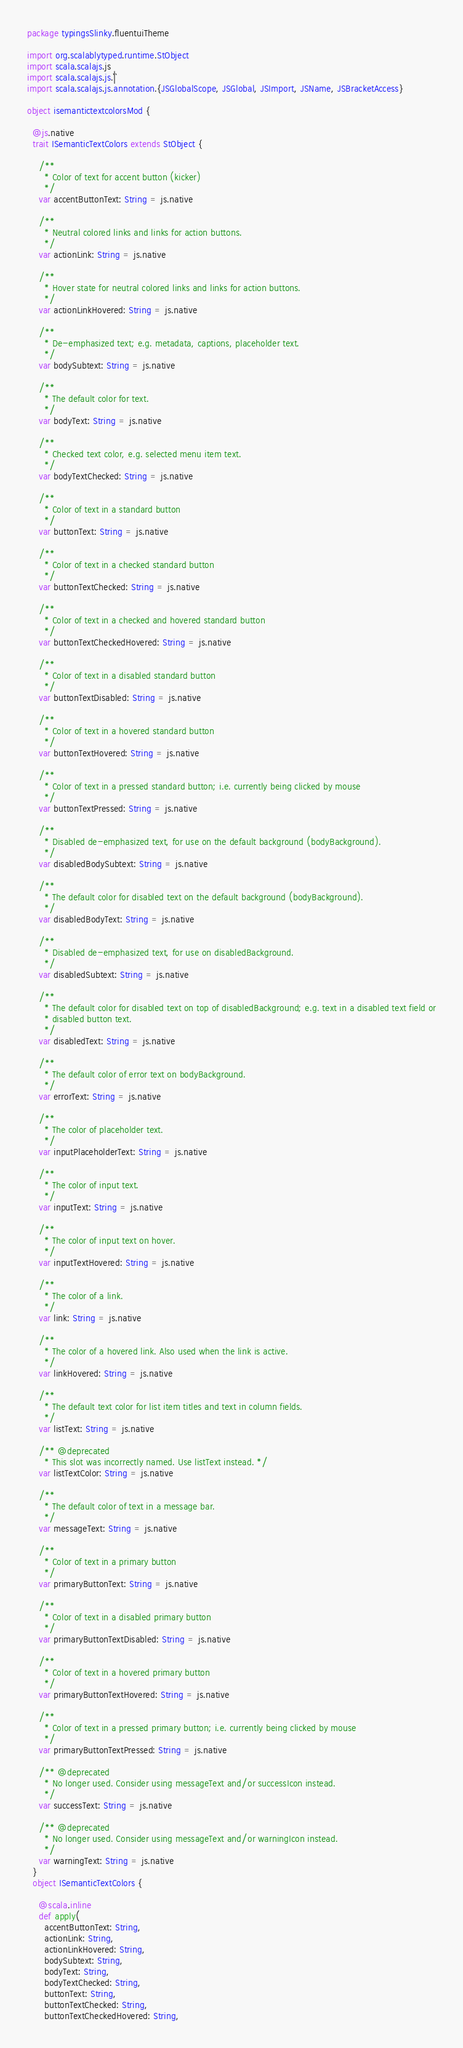Convert code to text. <code><loc_0><loc_0><loc_500><loc_500><_Scala_>package typingsSlinky.fluentuiTheme

import org.scalablytyped.runtime.StObject
import scala.scalajs.js
import scala.scalajs.js.`|`
import scala.scalajs.js.annotation.{JSGlobalScope, JSGlobal, JSImport, JSName, JSBracketAccess}

object isemantictextcolorsMod {
  
  @js.native
  trait ISemanticTextColors extends StObject {
    
    /**
      * Color of text for accent button (kicker)
      */
    var accentButtonText: String = js.native
    
    /**
      * Neutral colored links and links for action buttons.
      */
    var actionLink: String = js.native
    
    /**
      * Hover state for neutral colored links and links for action buttons.
      */
    var actionLinkHovered: String = js.native
    
    /**
      * De-emphasized text; e.g. metadata, captions, placeholder text.
      */
    var bodySubtext: String = js.native
    
    /**
      * The default color for text.
      */
    var bodyText: String = js.native
    
    /**
      * Checked text color, e.g. selected menu item text.
      */
    var bodyTextChecked: String = js.native
    
    /**
      * Color of text in a standard button
      */
    var buttonText: String = js.native
    
    /**
      * Color of text in a checked standard button
      */
    var buttonTextChecked: String = js.native
    
    /**
      * Color of text in a checked and hovered standard button
      */
    var buttonTextCheckedHovered: String = js.native
    
    /**
      * Color of text in a disabled standard button
      */
    var buttonTextDisabled: String = js.native
    
    /**
      * Color of text in a hovered standard button
      */
    var buttonTextHovered: String = js.native
    
    /**
      * Color of text in a pressed standard button; i.e. currently being clicked by mouse
      */
    var buttonTextPressed: String = js.native
    
    /**
      * Disabled de-emphasized text, for use on the default background (bodyBackground).
      */
    var disabledBodySubtext: String = js.native
    
    /**
      * The default color for disabled text on the default background (bodyBackground).
      */
    var disabledBodyText: String = js.native
    
    /**
      * Disabled de-emphasized text, for use on disabledBackground.
      */
    var disabledSubtext: String = js.native
    
    /**
      * The default color for disabled text on top of disabledBackground; e.g. text in a disabled text field or
      * disabled button text.
      */
    var disabledText: String = js.native
    
    /**
      * The default color of error text on bodyBackground.
      */
    var errorText: String = js.native
    
    /**
      * The color of placeholder text.
      */
    var inputPlaceholderText: String = js.native
    
    /**
      * The color of input text.
      */
    var inputText: String = js.native
    
    /**
      * The color of input text on hover.
      */
    var inputTextHovered: String = js.native
    
    /**
      * The color of a link.
      */
    var link: String = js.native
    
    /**
      * The color of a hovered link. Also used when the link is active.
      */
    var linkHovered: String = js.native
    
    /**
      * The default text color for list item titles and text in column fields.
      */
    var listText: String = js.native
    
    /** @deprecated
      * This slot was incorrectly named. Use listText instead. */
    var listTextColor: String = js.native
    
    /**
      * The default color of text in a message bar.
      */
    var messageText: String = js.native
    
    /**
      * Color of text in a primary button
      */
    var primaryButtonText: String = js.native
    
    /**
      * Color of text in a disabled primary button
      */
    var primaryButtonTextDisabled: String = js.native
    
    /**
      * Color of text in a hovered primary button
      */
    var primaryButtonTextHovered: String = js.native
    
    /**
      * Color of text in a pressed primary button; i.e. currently being clicked by mouse
      */
    var primaryButtonTextPressed: String = js.native
    
    /** @deprecated
      * No longer used. Consider using messageText and/or successIcon instead.
      */
    var successText: String = js.native
    
    /** @deprecated
      * No longer used. Consider using messageText and/or warningIcon instead.
      */
    var warningText: String = js.native
  }
  object ISemanticTextColors {
    
    @scala.inline
    def apply(
      accentButtonText: String,
      actionLink: String,
      actionLinkHovered: String,
      bodySubtext: String,
      bodyText: String,
      bodyTextChecked: String,
      buttonText: String,
      buttonTextChecked: String,
      buttonTextCheckedHovered: String,</code> 